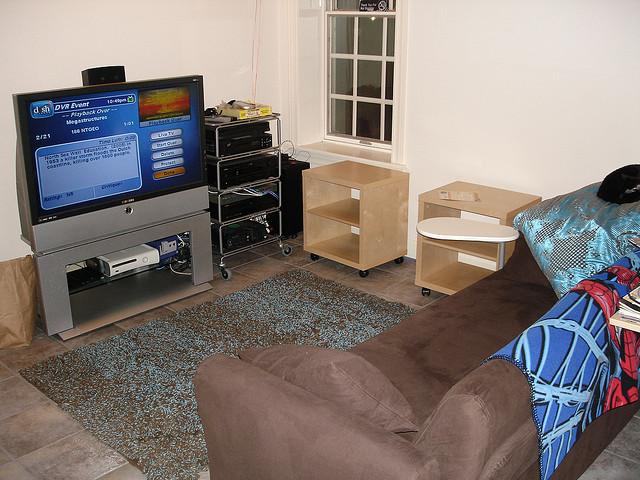What color is the sofa?
Keep it brief. Brown. Is the tv on?
Give a very brief answer. Yes. What superhero is on the blanket?
Write a very short answer. Spiderman. 